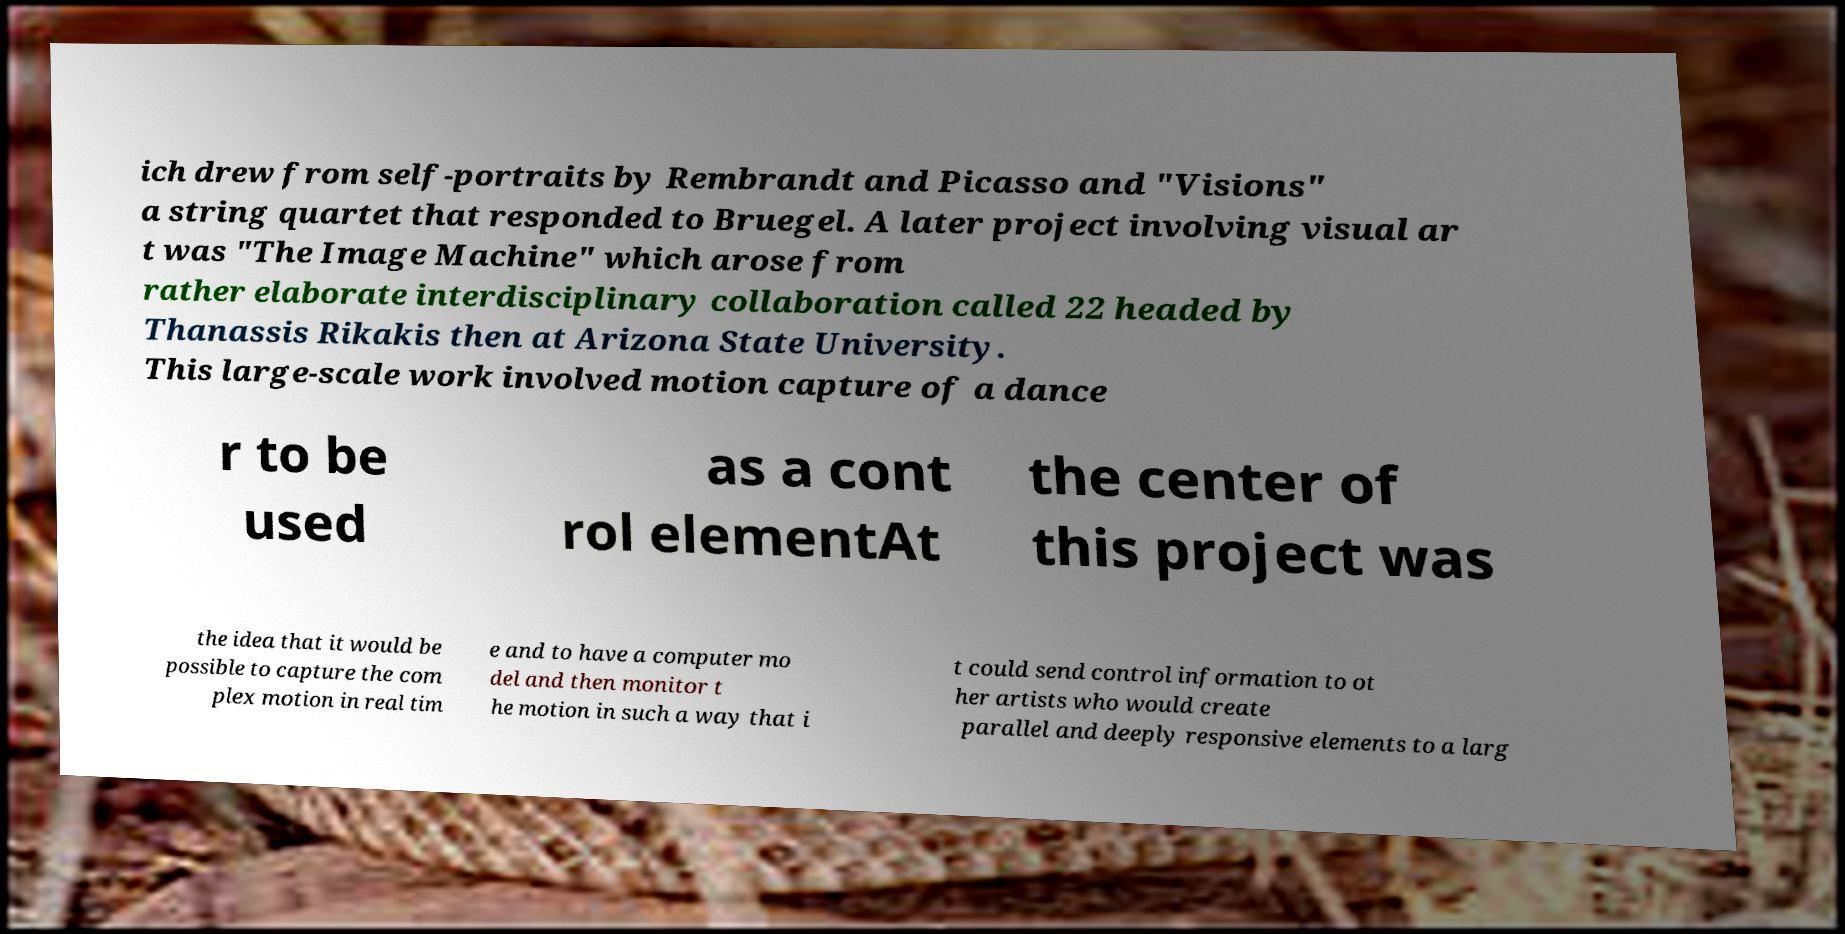I need the written content from this picture converted into text. Can you do that? ich drew from self-portraits by Rembrandt and Picasso and "Visions" a string quartet that responded to Bruegel. A later project involving visual ar t was "The Image Machine" which arose from rather elaborate interdisciplinary collaboration called 22 headed by Thanassis Rikakis then at Arizona State University. This large-scale work involved motion capture of a dance r to be used as a cont rol elementAt the center of this project was the idea that it would be possible to capture the com plex motion in real tim e and to have a computer mo del and then monitor t he motion in such a way that i t could send control information to ot her artists who would create parallel and deeply responsive elements to a larg 